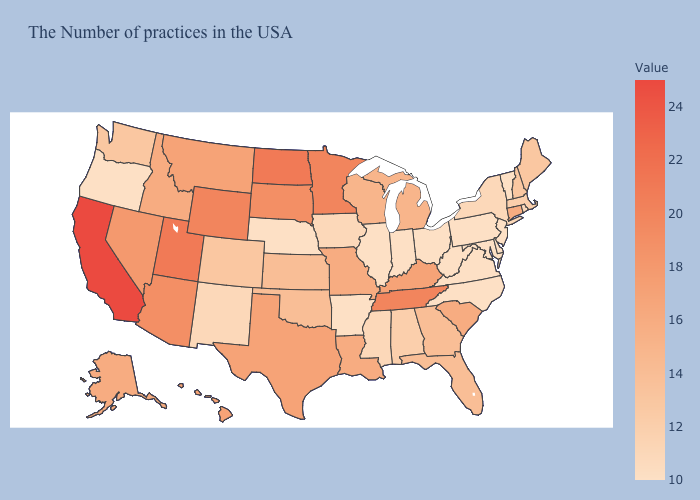Which states hav the highest value in the West?
Give a very brief answer. California. Does Tennessee have the highest value in the South?
Quick response, please. Yes. 